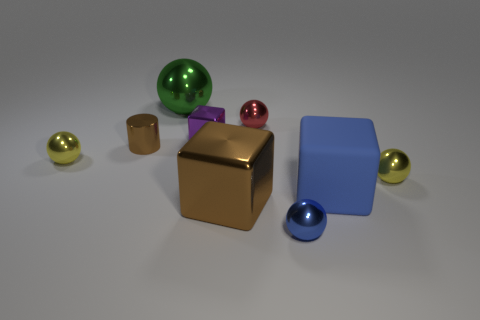The blue object that is the same size as the red metal object is what shape?
Offer a terse response. Sphere. What number of other things are there of the same color as the large shiny cube?
Make the answer very short. 1. What number of big brown cubes are there?
Keep it short and to the point. 1. How many things are in front of the big shiny ball and right of the tiny shiny cylinder?
Offer a very short reply. 6. What is the material of the red sphere?
Provide a succinct answer. Metal. Are there any purple metal objects?
Keep it short and to the point. Yes. The cylinder that is in front of the green shiny object is what color?
Provide a short and direct response. Brown. How many purple metallic objects are behind the tiny metal sphere that is behind the yellow sphere on the left side of the small blue metallic sphere?
Your response must be concise. 0. There is a sphere that is both behind the small cylinder and right of the purple metallic block; what is its material?
Your answer should be compact. Metal. Is the material of the tiny purple cube the same as the red thing that is behind the brown block?
Your answer should be compact. Yes. 